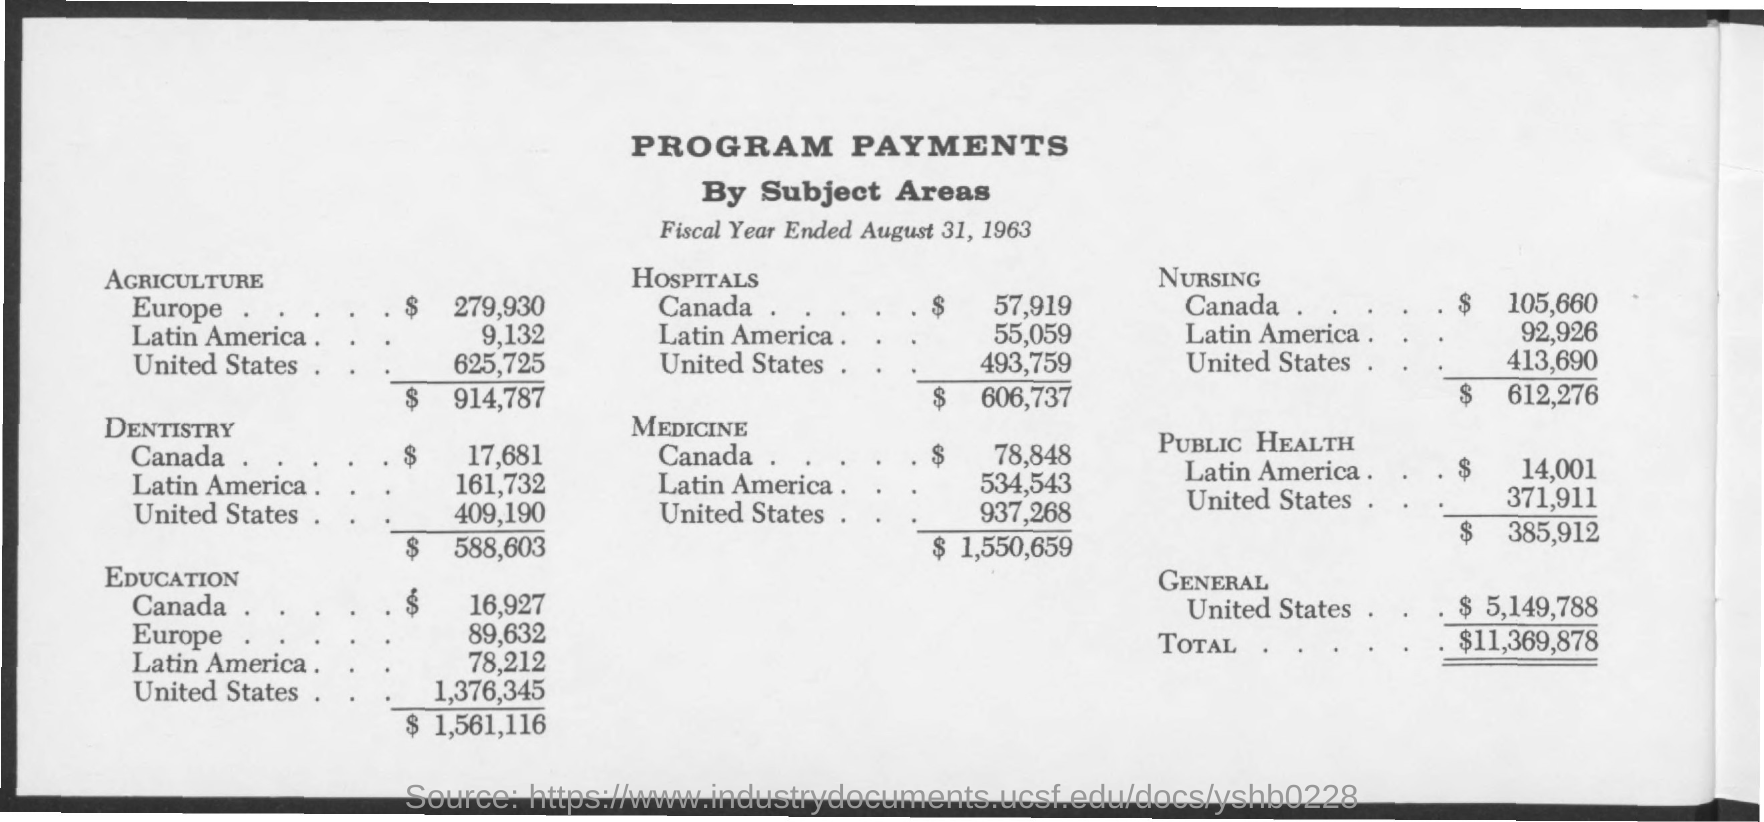Draw attention to some important aspects in this diagram. The most expensive program in the United States is education. The total for agriculture is $914,787. The Program payment for agriculture in Latin America is 9,132. The program payment for agriculture in the United States is 625,725. The program payment for dentistry in the United States is approximately $409,190. 